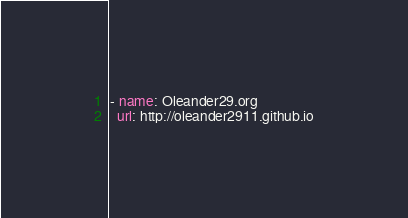<code> <loc_0><loc_0><loc_500><loc_500><_YAML_>- name: Oleander29.org 
  url: http://oleander2911.github.io
</code> 